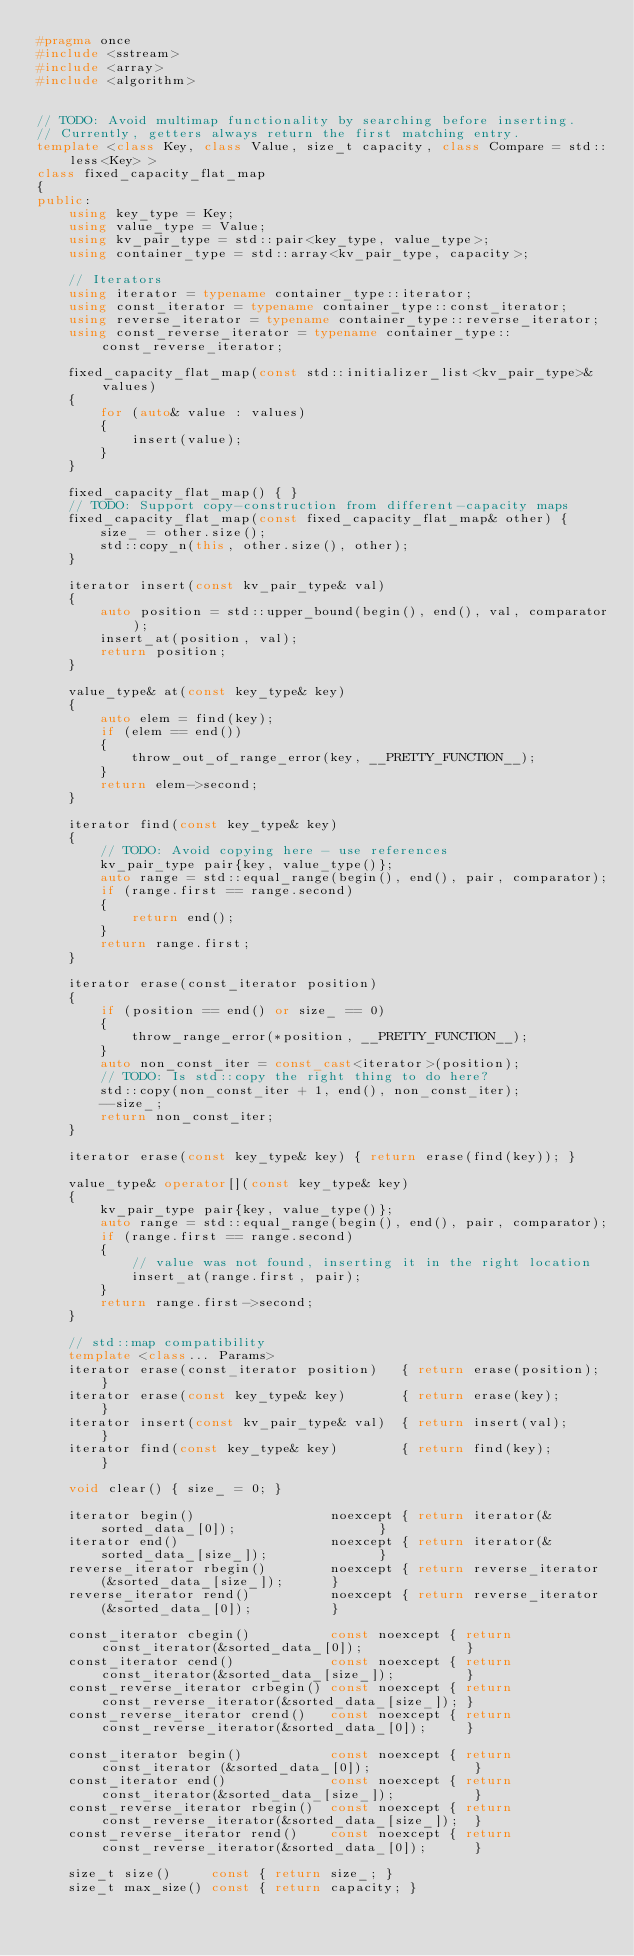Convert code to text. <code><loc_0><loc_0><loc_500><loc_500><_C++_>#pragma once
#include <sstream>
#include <array>
#include <algorithm>


// TODO: Avoid multimap functionality by searching before inserting.
// Currently, getters always return the first matching entry.
template <class Key, class Value, size_t capacity, class Compare = std::less<Key> >
class fixed_capacity_flat_map
{
public:
	using key_type = Key;
	using value_type = Value;
	using kv_pair_type = std::pair<key_type, value_type>;
	using container_type = std::array<kv_pair_type, capacity>;

	// Iterators
	using iterator = typename container_type::iterator;
	using const_iterator = typename container_type::const_iterator;
	using reverse_iterator = typename container_type::reverse_iterator;
	using const_reverse_iterator = typename container_type::const_reverse_iterator;

	fixed_capacity_flat_map(const std::initializer_list<kv_pair_type>& values)
	{
		for (auto& value : values)
		{
			insert(value);
		}
	}

	fixed_capacity_flat_map() { }
	// TODO: Support copy-construction from different-capacity maps
	fixed_capacity_flat_map(const fixed_capacity_flat_map& other) { 
		size_ = other.size();
		std::copy_n(this, other.size(), other); 
	}

	iterator insert(const kv_pair_type& val)
	{
		auto position = std::upper_bound(begin(), end(), val, comparator);
		insert_at(position, val);
		return position;
	}

	value_type& at(const key_type& key)
	{
		auto elem = find(key);
		if (elem == end())
		{
			throw_out_of_range_error(key, __PRETTY_FUNCTION__);
		}
		return elem->second;
	}

	iterator find(const key_type& key)
	{
		// TODO: Avoid copying here - use references
		kv_pair_type pair{key, value_type()};
		auto range = std::equal_range(begin(), end(), pair, comparator);
		if (range.first == range.second)
		{
			return end();
		}
		return range.first;
	}

	iterator erase(const_iterator position)
	{
		if (position == end() or size_ == 0)
		{
			throw_range_error(*position, __PRETTY_FUNCTION__);
		}
		auto non_const_iter = const_cast<iterator>(position);
		// TODO: Is std::copy the right thing to do here?
		std::copy(non_const_iter + 1, end(), non_const_iter);
		--size_;
		return non_const_iter;
	}

	iterator erase(const key_type& key) { return erase(find(key)); }

	value_type& operator[](const key_type& key)
	{
		kv_pair_type pair{key, value_type()};
		auto range = std::equal_range(begin(), end(), pair, comparator);
		if (range.first == range.second)
		{
			// value was not found, inserting it in the right location
			insert_at(range.first, pair);
		}
		return range.first->second;
	}

	// std::map compatibility
	template <class... Params>
	iterator erase(const_iterator position)   { return erase(position); }
	iterator erase(const key_type& key)       { return erase(key);      }
	iterator insert(const kv_pair_type& val)  { return insert(val);     }
	iterator find(const key_type& key)        { return find(key);       }

	void clear() { size_ = 0; }

	iterator begin()                 noexcept { return iterator(&sorted_data_[0]);                  }
	iterator end()                   noexcept { return iterator(&sorted_data_[size_]);              }
	reverse_iterator rbegin()        noexcept { return reverse_iterator(&sorted_data_[size_]);      }
	reverse_iterator rend()          noexcept { return reverse_iterator(&sorted_data_[0]);          }

	const_iterator cbegin()          const noexcept { return const_iterator(&sorted_data_[0]);             }
	const_iterator cend()            const noexcept { return const_iterator(&sorted_data_[size_]);         }
	const_reverse_iterator crbegin() const noexcept { return const_reverse_iterator(&sorted_data_[size_]); }
	const_reverse_iterator crend()   const noexcept { return const_reverse_iterator(&sorted_data_[0]);     }

	const_iterator begin()           const noexcept { return const_iterator (&sorted_data_[0]);             }
	const_iterator end()             const noexcept { return const_iterator(&sorted_data_[size_]);          }
	const_reverse_iterator rbegin()  const noexcept { return const_reverse_iterator(&sorted_data_[size_]);  }
	const_reverse_iterator rend()    const noexcept { return const_reverse_iterator(&sorted_data_[0]);      }

	size_t size()     const { return size_; }
	size_t max_size() const { return capacity; }</code> 